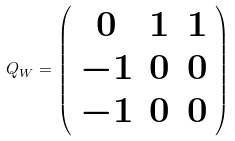Convert formula to latex. <formula><loc_0><loc_0><loc_500><loc_500>Q _ { W } = \left ( \begin{array} { c c c } 0 & 1 & 1 \\ - 1 & 0 & 0 \\ - 1 & 0 & 0 \end{array} \right ) \</formula> 